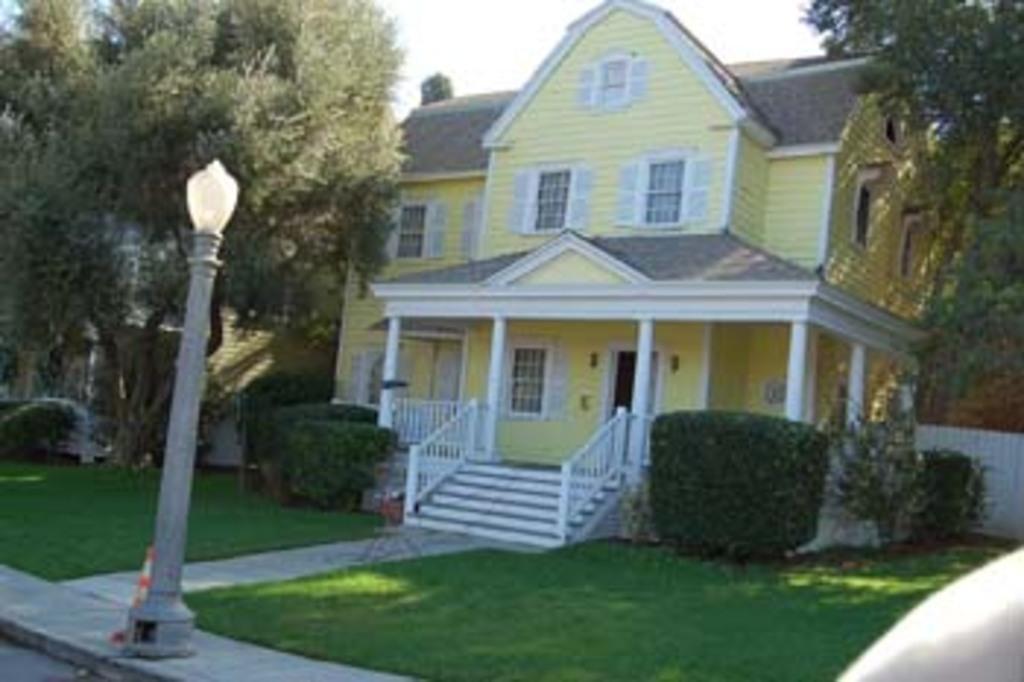Could you give a brief overview of what you see in this image? In this picture we can see light pole, grass, plants, trees and house. In the background of the image we can see the sky. 